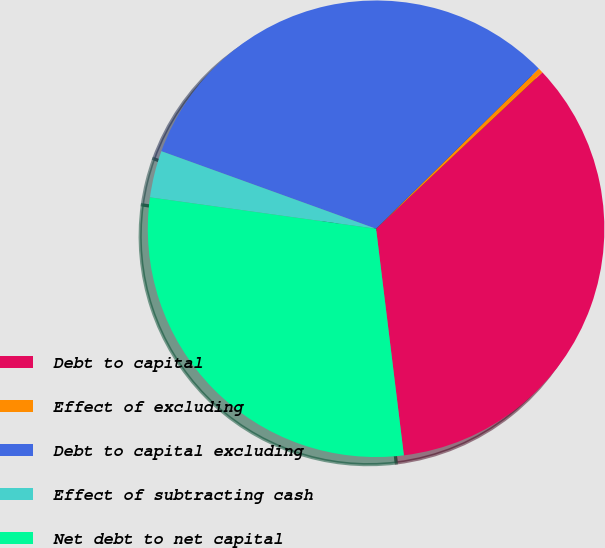Convert chart. <chart><loc_0><loc_0><loc_500><loc_500><pie_chart><fcel>Debt to capital<fcel>Effect of excluding<fcel>Debt to capital excluding<fcel>Effect of subtracting cash<fcel>Net debt to net capital<nl><fcel>35.07%<fcel>0.36%<fcel>32.11%<fcel>3.32%<fcel>29.14%<nl></chart> 